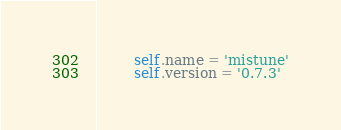<code> <loc_0><loc_0><loc_500><loc_500><_Python_>        self.name = 'mistune'
        self.version = '0.7.3'
</code> 